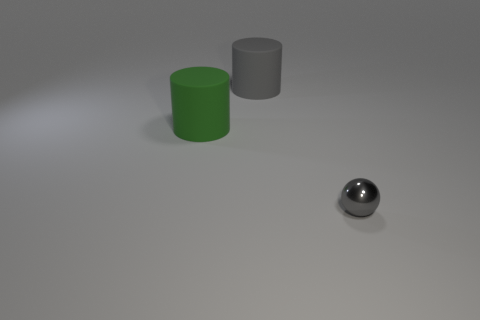Is there anything else that is the same shape as the large gray object?
Give a very brief answer. Yes. Is the green object the same shape as the gray matte thing?
Provide a short and direct response. Yes. Are there an equal number of large gray cylinders that are to the left of the green matte thing and matte objects that are behind the big gray cylinder?
Your answer should be very brief. Yes. How many other objects are there of the same material as the large green cylinder?
Your answer should be very brief. 1. What number of large objects are gray balls or cylinders?
Provide a short and direct response. 2. Is the number of large green matte cylinders that are on the right side of the gray sphere the same as the number of tiny things?
Provide a short and direct response. No. Is there a large green rubber object behind the gray thing that is behind the small object?
Provide a succinct answer. No. What number of other objects are there of the same color as the small thing?
Ensure brevity in your answer.  1. What is the color of the small metallic ball?
Offer a very short reply. Gray. There is a object that is both in front of the large gray rubber object and on the left side of the gray metal ball; what size is it?
Your answer should be compact. Large. 